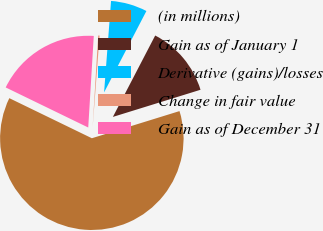<chart> <loc_0><loc_0><loc_500><loc_500><pie_chart><fcel>(in millions)<fcel>Gain as of January 1<fcel>Derivative (gains)/losses<fcel>Change in fair value<fcel>Gain as of December 31<nl><fcel>61.98%<fcel>12.59%<fcel>6.42%<fcel>0.25%<fcel>18.77%<nl></chart> 